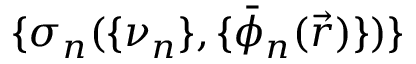Convert formula to latex. <formula><loc_0><loc_0><loc_500><loc_500>\{ \sigma _ { n } ( \{ \nu _ { n } \} , \{ \bar { \phi } _ { n } ( \vec { r } ) \} ) \}</formula> 